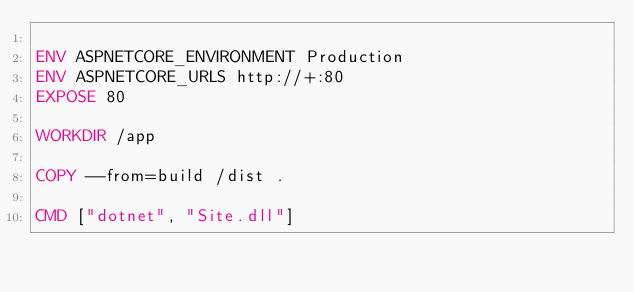Convert code to text. <code><loc_0><loc_0><loc_500><loc_500><_Dockerfile_>
ENV ASPNETCORE_ENVIRONMENT Production
ENV ASPNETCORE_URLS http://+:80
EXPOSE 80

WORKDIR /app

COPY --from=build /dist .

CMD ["dotnet", "Site.dll"]
</code> 